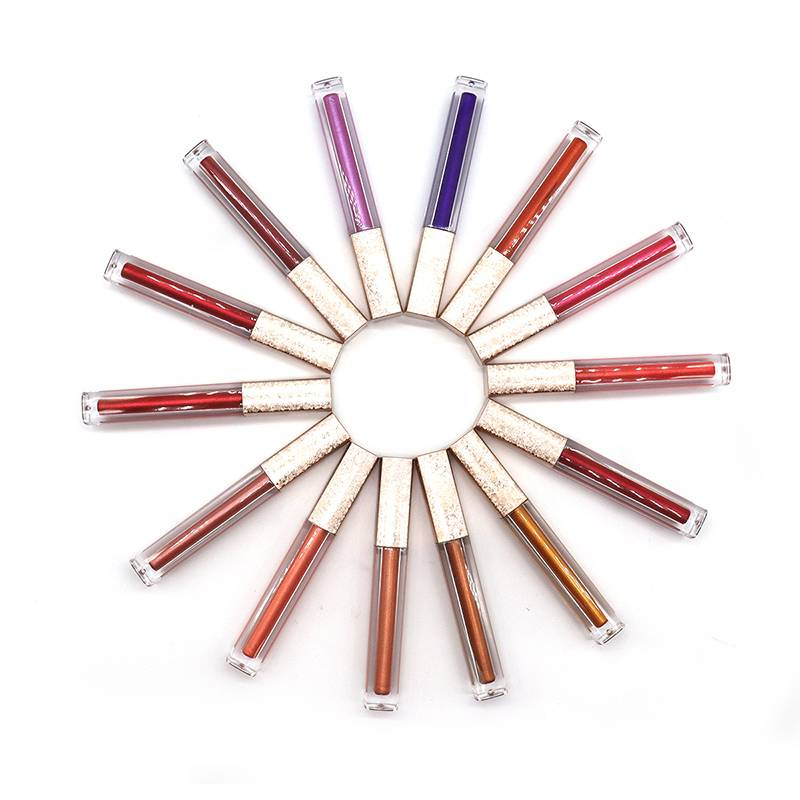What does the arrangement of the lip gloss tubes suggest about the brand's aesthetic? The arrangement of the lip gloss tubes, fanning out in a circular pattern with a clean background, hints at a brand's aesthetic that values elegance, simplicity, and sophistication. The uniformity of the packaging design suggests a cohesive collection, possibly targeting consumers who appreciate minimalist beauty products with a touch of luxury. Could this presentation say anything about the target demographic? Yes, the chic and orderly presentation may indicate that the brand is targeting a demographic that favors classic styles and possibly an age group that is professional and values quality. The absence of overly bright or whimsical colors suggests a focus on timeless appeal rather than transient trends. 